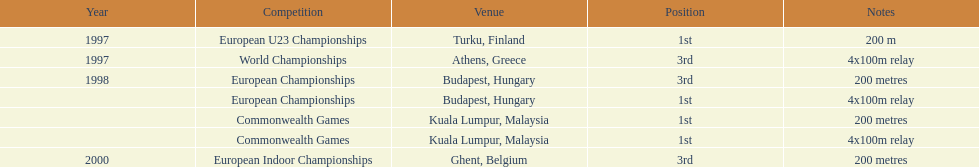How many total years did golding compete? 3. 